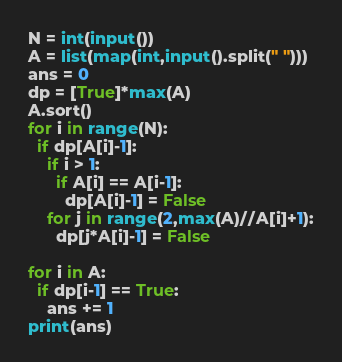<code> <loc_0><loc_0><loc_500><loc_500><_Python_>N = int(input())
A = list(map(int,input().split(" ")))
ans = 0
dp = [True]*max(A)
A.sort()
for i in range(N):
  if dp[A[i]-1]:
    if i > 1:
      if A[i] == A[i-1]:
        dp[A[i]-1] = False
    for j in range(2,max(A)//A[i]+1):
      dp[j*A[i]-1] = False 

for i in A:
  if dp[i-1] == True:
    ans += 1
print(ans)</code> 